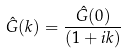<formula> <loc_0><loc_0><loc_500><loc_500>\hat { G } ( k ) = \frac { \hat { G } ( 0 ) } { ( 1 + i k ) }</formula> 